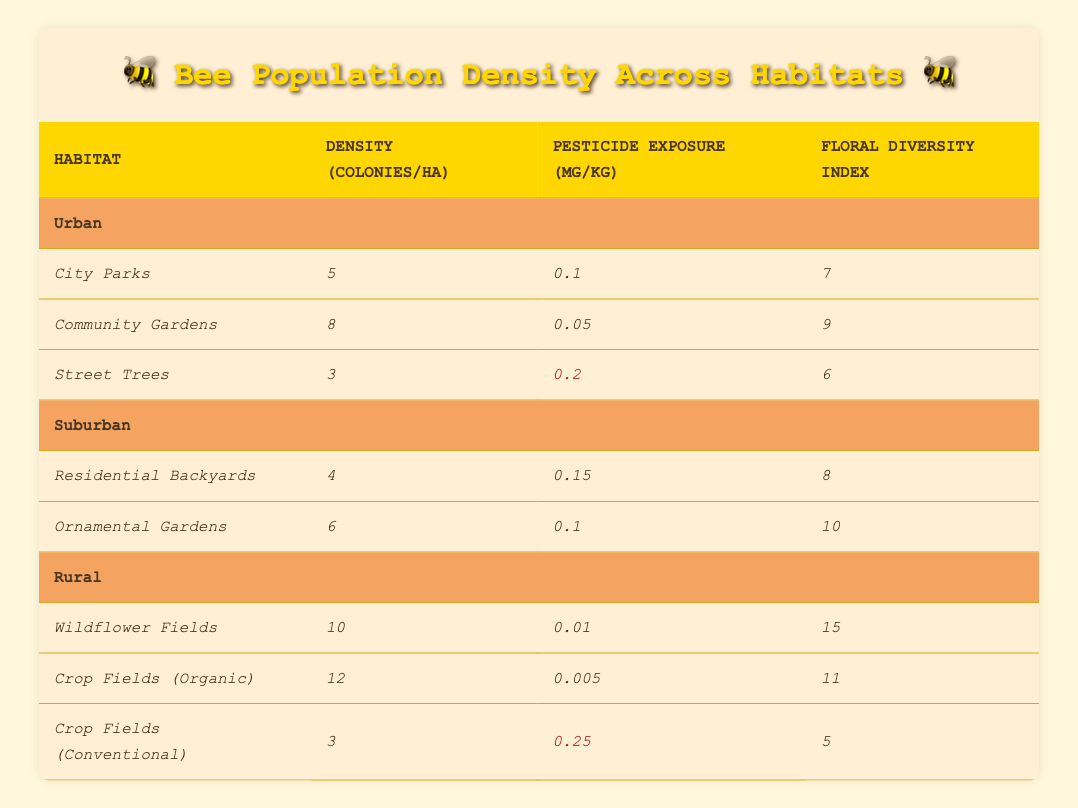What is the highest bee population density recorded in the table? By examining the "Density (colonies/ha)" column across all habitats, the maximum value appears under "Crop Fields (Organic)" with a density of 12 colonies per hectare.
Answer: 12 Is the pesticide exposure higher in Urban Street Trees than in Rural Wildflower Fields? Urban Street Trees have a pesticide exposure of 0.2 mg/kg, while Rural Wildflower Fields have only 0.01 mg/kg. Comparing both values, Urban Street Trees have higher exposure.
Answer: Yes What is the average floral diversity index across all habitats? To find the average, we sum the floral diversity index values: 7 (City Parks) + 9 (Community Gardens) + 6 (Street Trees) + 8 (Residential Backyards) + 10 (Ornamental Gardens) + 15 (Wildflower Fields) + 11 (Crop Fields Organic) + 5 (Crop Fields Conventional) = 71. There are 8 data points, so the average is 71/8 = 8.875.
Answer: 8.875 Which habitat has the lowest pesticide exposure and what is that value? Inspecting the "Pesticide Exposure (mg/kg)" column, "Crop Fields (Organic)" has the lowest value at 0.005 mg/kg.
Answer: 0.005 Are there any habitats classified as Urban that have a floral diversity index of 9 or more? Looking at the Urban habitats, both "Community Gardens" (with an index of 9) and "City Parks" (7) are listed. This means there is at least one Urban habitat that meets the criteria.
Answer: Yes What is the difference in bee population density between Rural Wildflower Fields and Urban City Parks? The density in Rural Wildflower Fields is 10 colonies/ha and in Urban City Parks it is 5 colonies/ha. The difference is calculated as 10 - 5 = 5 colonies/ha.
Answer: 5 In which habitat type is the pesticide exposure highest? By comparing all habitats in the "Pesticide Exposure (mg/kg)" column, the highest value is found in "Crop Fields (Conventional)" at 0.25 mg/kg.
Answer: Crop Fields (Conventional) How many Urban habitats are listed in the table? The Urban section contains three habitats: "City Parks," "Community Gardens," and "Street Trees." Thus, there are a total of three Urban habitats.
Answer: 3 What's the floral diversity index for Crop Fields (Organic) and how does it compare to Residential Backyards? The floral diversity index for "Crop Fields (Organic)" is 11, while "Residential Backyards" has an index of 8. Therefore, "Crop Fields (Organic)" has a higher floral diversity index than "Residential Backyards."
Answer: Higher 